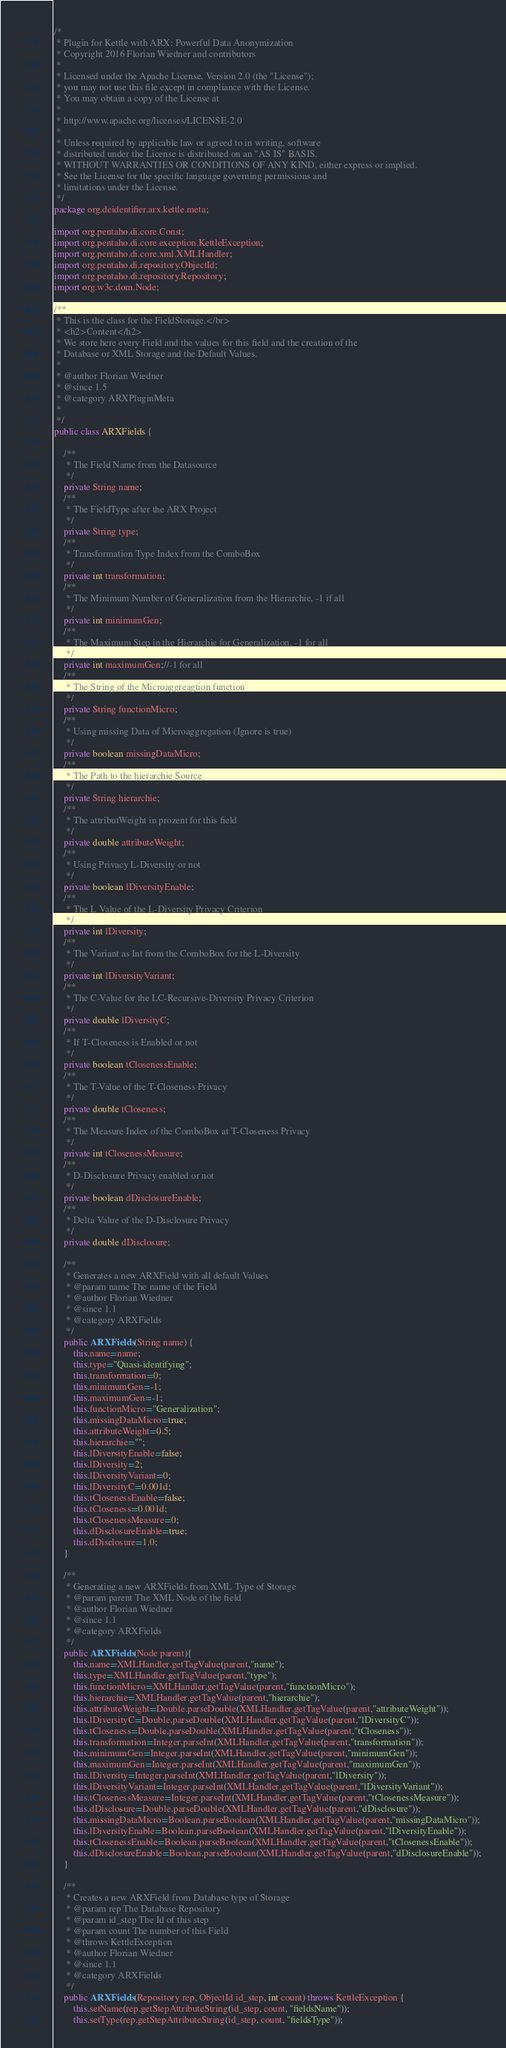Convert code to text. <code><loc_0><loc_0><loc_500><loc_500><_Java_>/*
 * Plugin for Kettle with ARX: Powerful Data Anonymization
 * Copyright 2016 Florian Wiedner and contributors
 * 
 * Licensed under the Apache License, Version 2.0 (the "License");
 * you may not use this file except in compliance with the License.
 * You may obtain a copy of the License at
 * 
 * http://www.apache.org/licenses/LICENSE-2.0
 * 
 * Unless required by applicable law or agreed to in writing, software
 * distributed under the License is distributed on an "AS IS" BASIS,
 * WITHOUT WARRANTIES OR CONDITIONS OF ANY KIND, either express or implied.
 * See the License for the specific language governing permissions and
 * limitations under the License.
 */
package org.deidentifier.arx.kettle.meta;

import org.pentaho.di.core.Const;
import org.pentaho.di.core.exception.KettleException;
import org.pentaho.di.core.xml.XMLHandler;
import org.pentaho.di.repository.ObjectId;
import org.pentaho.di.repository.Repository;
import org.w3c.dom.Node;

/**
 * This is the class for the FieldStorage.</br>
 * <h2>Content</h2>
 * We store here every Field and the values for this field and the creation of the
 * Database or XML Storage and the Default Values.
 * 
 * @author Florian Wiedner
 * @since 1.5
 * @category ARXPluginMeta
 *
 */
public class ARXFields {

	/**
	 * The Field Name from the Datasource
	 */
	private String name;
	/**
	 * The FieldType after the ARX Project
	 */
	private String type;
	/**
	 * Transformation Type Index from the ComboBox 
	 */
	private int transformation;
	/**
	 * The Minimum Number of Generalization from the Hierarchie, -1 if all
	 */
	private int minimumGen;
	/**
	 * The Maximum Step in the Hierarchie for Generalization, -1 for all
	 */
	private int maximumGen;//-1 for all
	/**
	 * The String of the Microaggreagtion function
	 */
	private String functionMicro;
	/**
	 * Using missing Data of Microaggregation (Ignore is true)
	 */
	private boolean missingDataMicro;
	/**
	 * The Path to the hierarchie Source
	 */
	private String hierarchie;
	/**
	 * The attributWeight in prozent for this field
	 */
	private double attributeWeight;
	/**
	 * Using Privacy L-Diversity or not
	 */
	private boolean lDiversityEnable;
	/**
	 * The L Value of the L-Diversity Privacy Criterion
	 */
	private int lDiversity;
	/**
	 * The Variant as Int from the ComboBox for the L-Diversity
	 */
	private int lDiversityVariant;
	/**
	 * The C-Value for the LC-Recursive-Diversity Privacy Criterion
	 */
	private double lDiversityC;
	/**
	 * If T-Closeness is Enabled or not
	 */
	private boolean tClosenessEnable;
	/**
	 * The T-Value of the T-Closeness Privacy
	 */
	private double tCloseness;
	/**
	 * The Measure Index of the ComboBox at T-Closeness Privacy
	 */
	private int tClosenessMeasure;
	/**
	 * D-Disclosure Privacy enabled or not
	 */
	private boolean dDisclosureEnable;
	/**
	 * Delta Value of the D-Disclosure Privacy
	 */
	private double dDisclosure;
	
	/**
	 * Generates a new ARXField with all default Values
	 * @param name The name of the Field
	 * @author Florian Wiedner
	 * @since 1.1
	 * @category ARXFields
	 */
	public ARXFields(String name) {
		this.name=name;
		this.type="Quasi-identifying";
		this.transformation=0;
		this.minimumGen=-1;
		this.maximumGen=-1;
		this.functionMicro="Generalization";
		this.missingDataMicro=true;
		this.attributeWeight=0.5;
		this.hierarchie="";
		this.lDiversityEnable=false;
		this.lDiversity=2;
		this.lDiversityVariant=0;
		this.lDiversityC=0.001d;
		this.tClosenessEnable=false;
		this.tCloseness=0.001d;
		this.tClosenessMeasure=0;
		this.dDisclosureEnable=true;
		this.dDisclosure=1.0;
	}
	
	/**
	 * Generating a new ARXFields from XML Type of Storage
	 * @param parent The XML Node of the field
	 * @author Florian Wiedner
	 * @since 1.1
	 * @category ARXFields
	 */
	public ARXFields(Node parent){
		this.name=XMLHandler.getTagValue(parent,"name");
		this.type=XMLHandler.getTagValue(parent,"type");
		this.functionMicro=XMLHandler.getTagValue(parent,"functionMicro");
		this.hierarchie=XMLHandler.getTagValue(parent,"hierarchie");
		this.attributeWeight=Double.parseDouble(XMLHandler.getTagValue(parent,"attributeWeight"));
		this.lDiversityC=Double.parseDouble(XMLHandler.getTagValue(parent,"lDiversityC"));
		this.tCloseness=Double.parseDouble(XMLHandler.getTagValue(parent,"tCloseness"));
		this.transformation=Integer.parseInt(XMLHandler.getTagValue(parent,"transformation"));
		this.minimumGen=Integer.parseInt(XMLHandler.getTagValue(parent,"minimumGen"));
		this.maximumGen=Integer.parseInt(XMLHandler.getTagValue(parent,"maximumGen"));
		this.lDiversity=Integer.parseInt(XMLHandler.getTagValue(parent,"lDiversity"));
		this.lDiversityVariant=Integer.parseInt(XMLHandler.getTagValue(parent,"lDiversityVariant"));
		this.tClosenessMeasure=Integer.parseInt(XMLHandler.getTagValue(parent,"tClosenessMeasure"));
		this.dDisclosure=Double.parseDouble(XMLHandler.getTagValue(parent,"dDisclosure"));
		this.missingDataMicro=Boolean.parseBoolean(XMLHandler.getTagValue(parent,"missingDataMicro"));
		this.lDiversityEnable=Boolean.parseBoolean(XMLHandler.getTagValue(parent,"lDiversityEnable"));
		this.tClosenessEnable=Boolean.parseBoolean(XMLHandler.getTagValue(parent,"tClosenessEnable"));
		this.dDisclosureEnable=Boolean.parseBoolean(XMLHandler.getTagValue(parent,"dDisclosureEnable"));
	}
	
	/**
	 * Creates a new ARXField from Database type of Storage
	 * @param rep The Database Repository
	 * @param id_step The Id of this step
	 * @param count The number of this Field
	 * @throws KettleException
	 * @author Florian Wiedner
	 * @since 1.1
	 * @category ARXFields
	 */
	public ARXFields(Repository rep, ObjectId id_step, int count) throws KettleException {
		this.setName(rep.getStepAttributeString(id_step, count, "fieldsName"));
		this.setType(rep.getStepAttributeString(id_step, count, "fieldsType"));</code> 